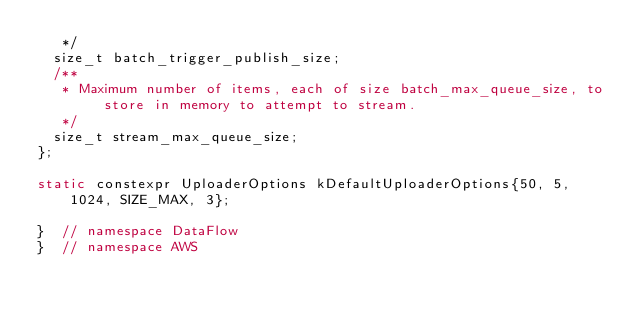Convert code to text. <code><loc_0><loc_0><loc_500><loc_500><_C_>   */
  size_t batch_trigger_publish_size;
  /**
   * Maximum number of items, each of size batch_max_queue_size, to store in memory to attempt to stream.
   */
  size_t stream_max_queue_size;
};

static constexpr UploaderOptions kDefaultUploaderOptions{50, 5, 1024, SIZE_MAX, 3};

}  // namespace DataFlow
}  // namespace AWS

</code> 